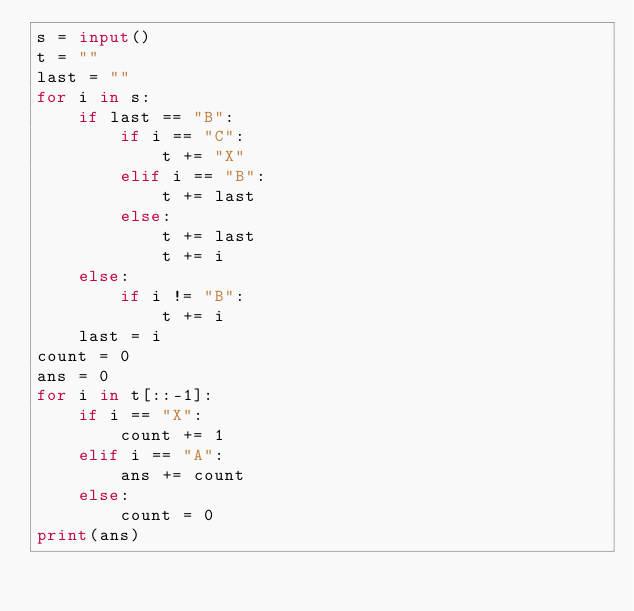Convert code to text. <code><loc_0><loc_0><loc_500><loc_500><_Python_>s = input()
t = ""
last = ""
for i in s:
    if last == "B":
        if i == "C":
            t += "X"
        elif i == "B":
            t += last
        else:
            t += last
            t += i
    else:
        if i != "B":
            t += i
    last = i
count = 0
ans = 0
for i in t[::-1]:
    if i == "X":
        count += 1
    elif i == "A":
        ans += count
    else:
        count = 0
print(ans)</code> 